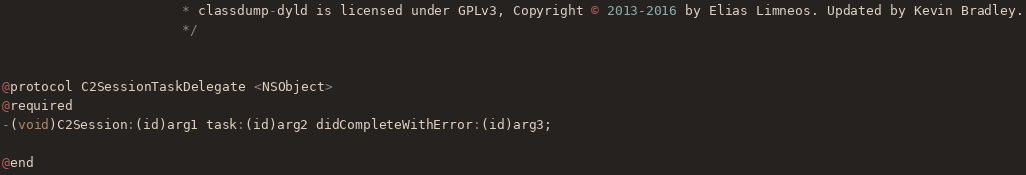Convert code to text. <code><loc_0><loc_0><loc_500><loc_500><_C_>                       * classdump-dyld is licensed under GPLv3, Copyright © 2013-2016 by Elias Limneos. Updated by Kevin Bradley.
                       */


@protocol C2SessionTaskDelegate <NSObject>
@required
-(void)C2Session:(id)arg1 task:(id)arg2 didCompleteWithError:(id)arg3;

@end

</code> 